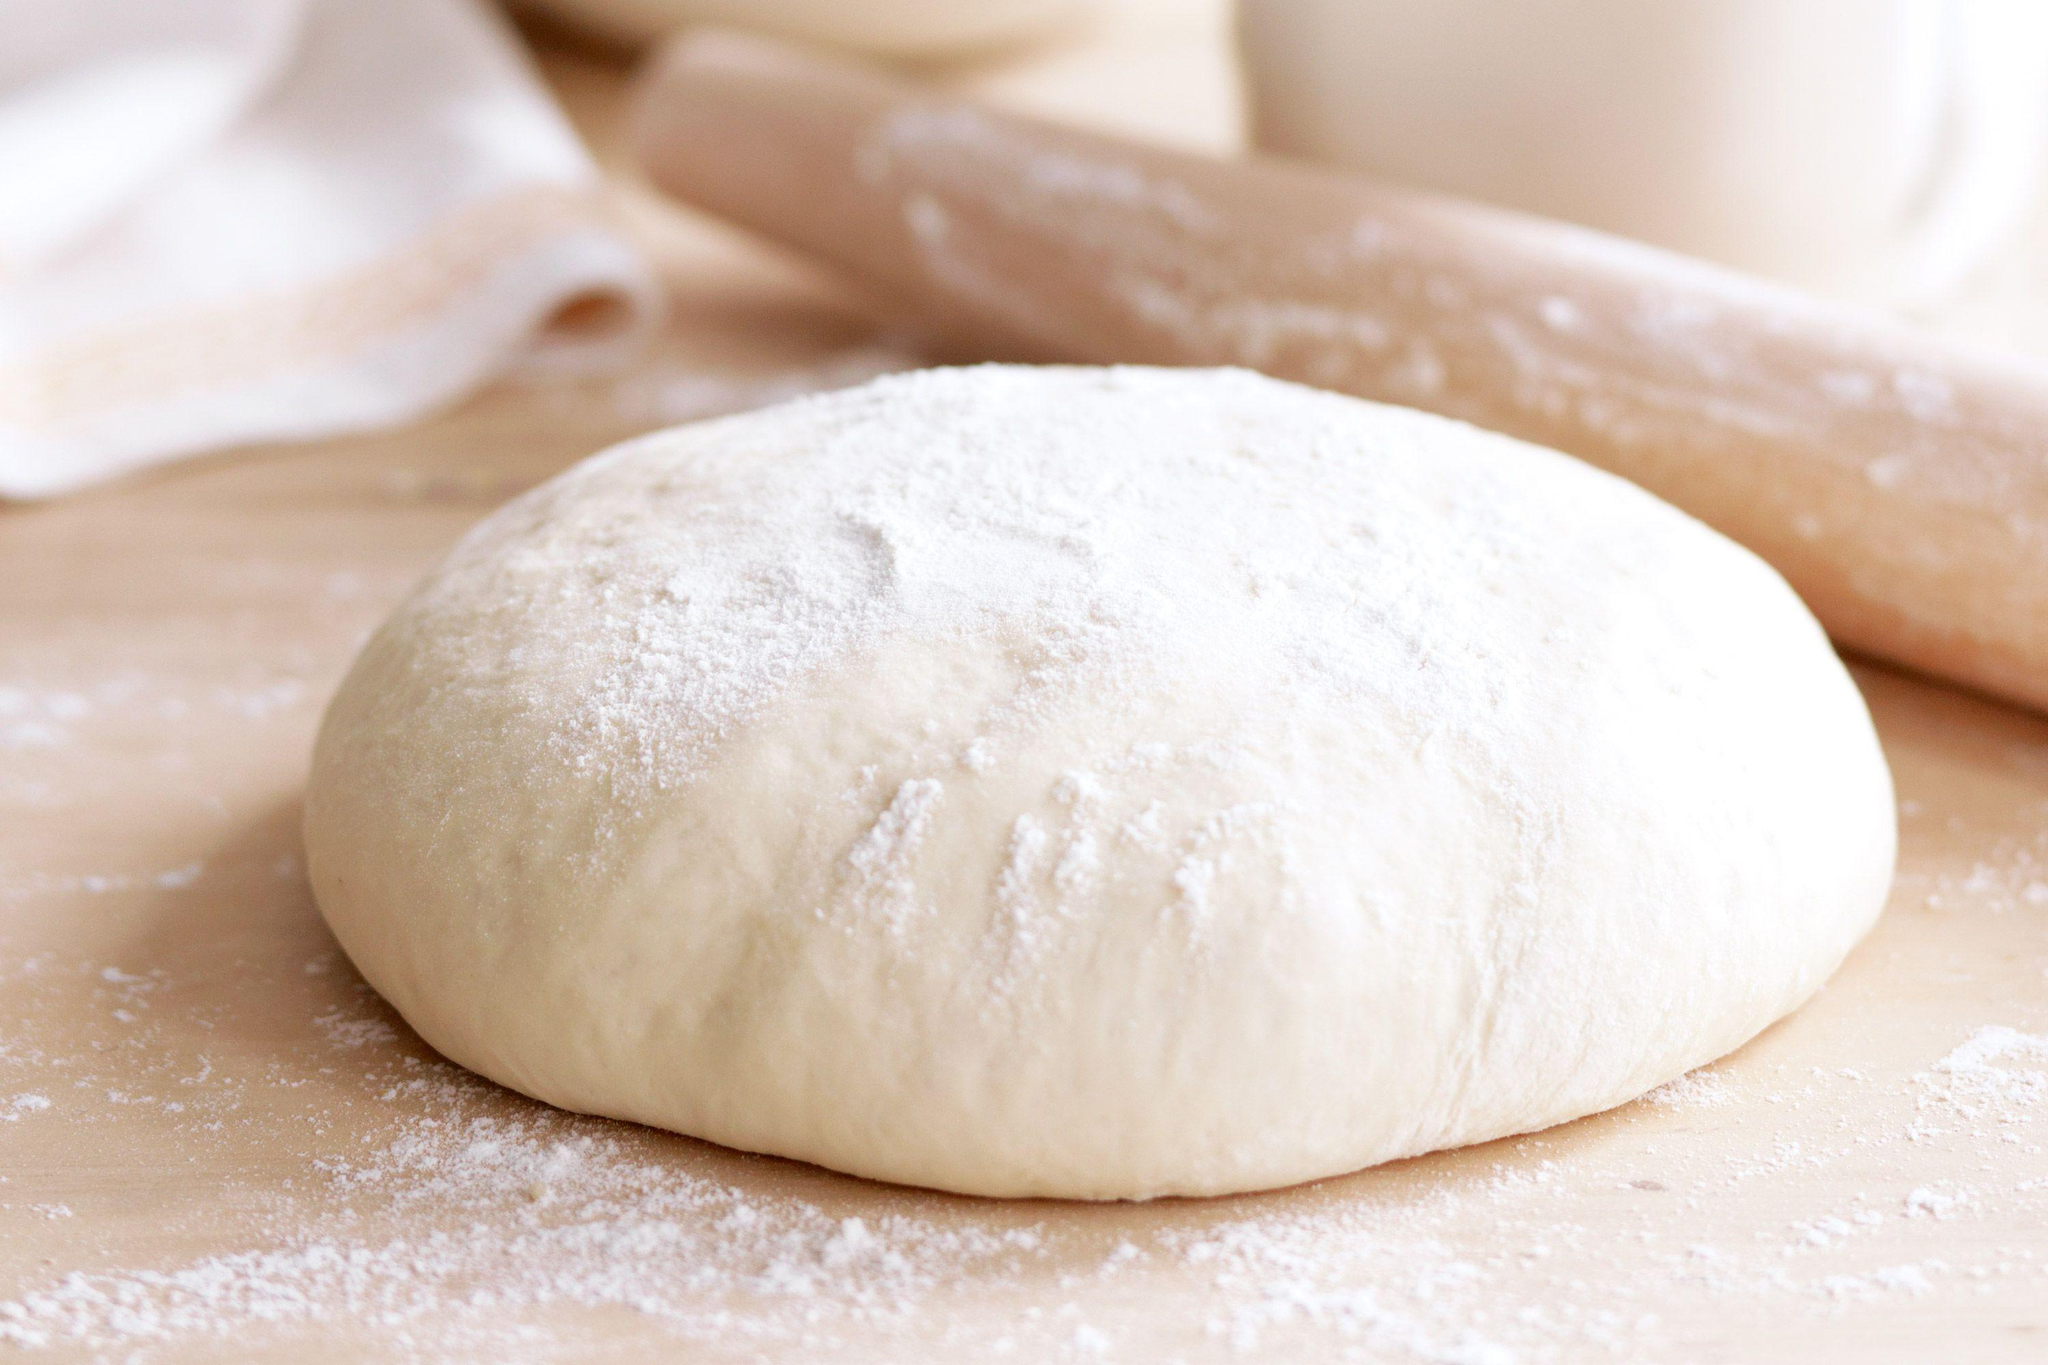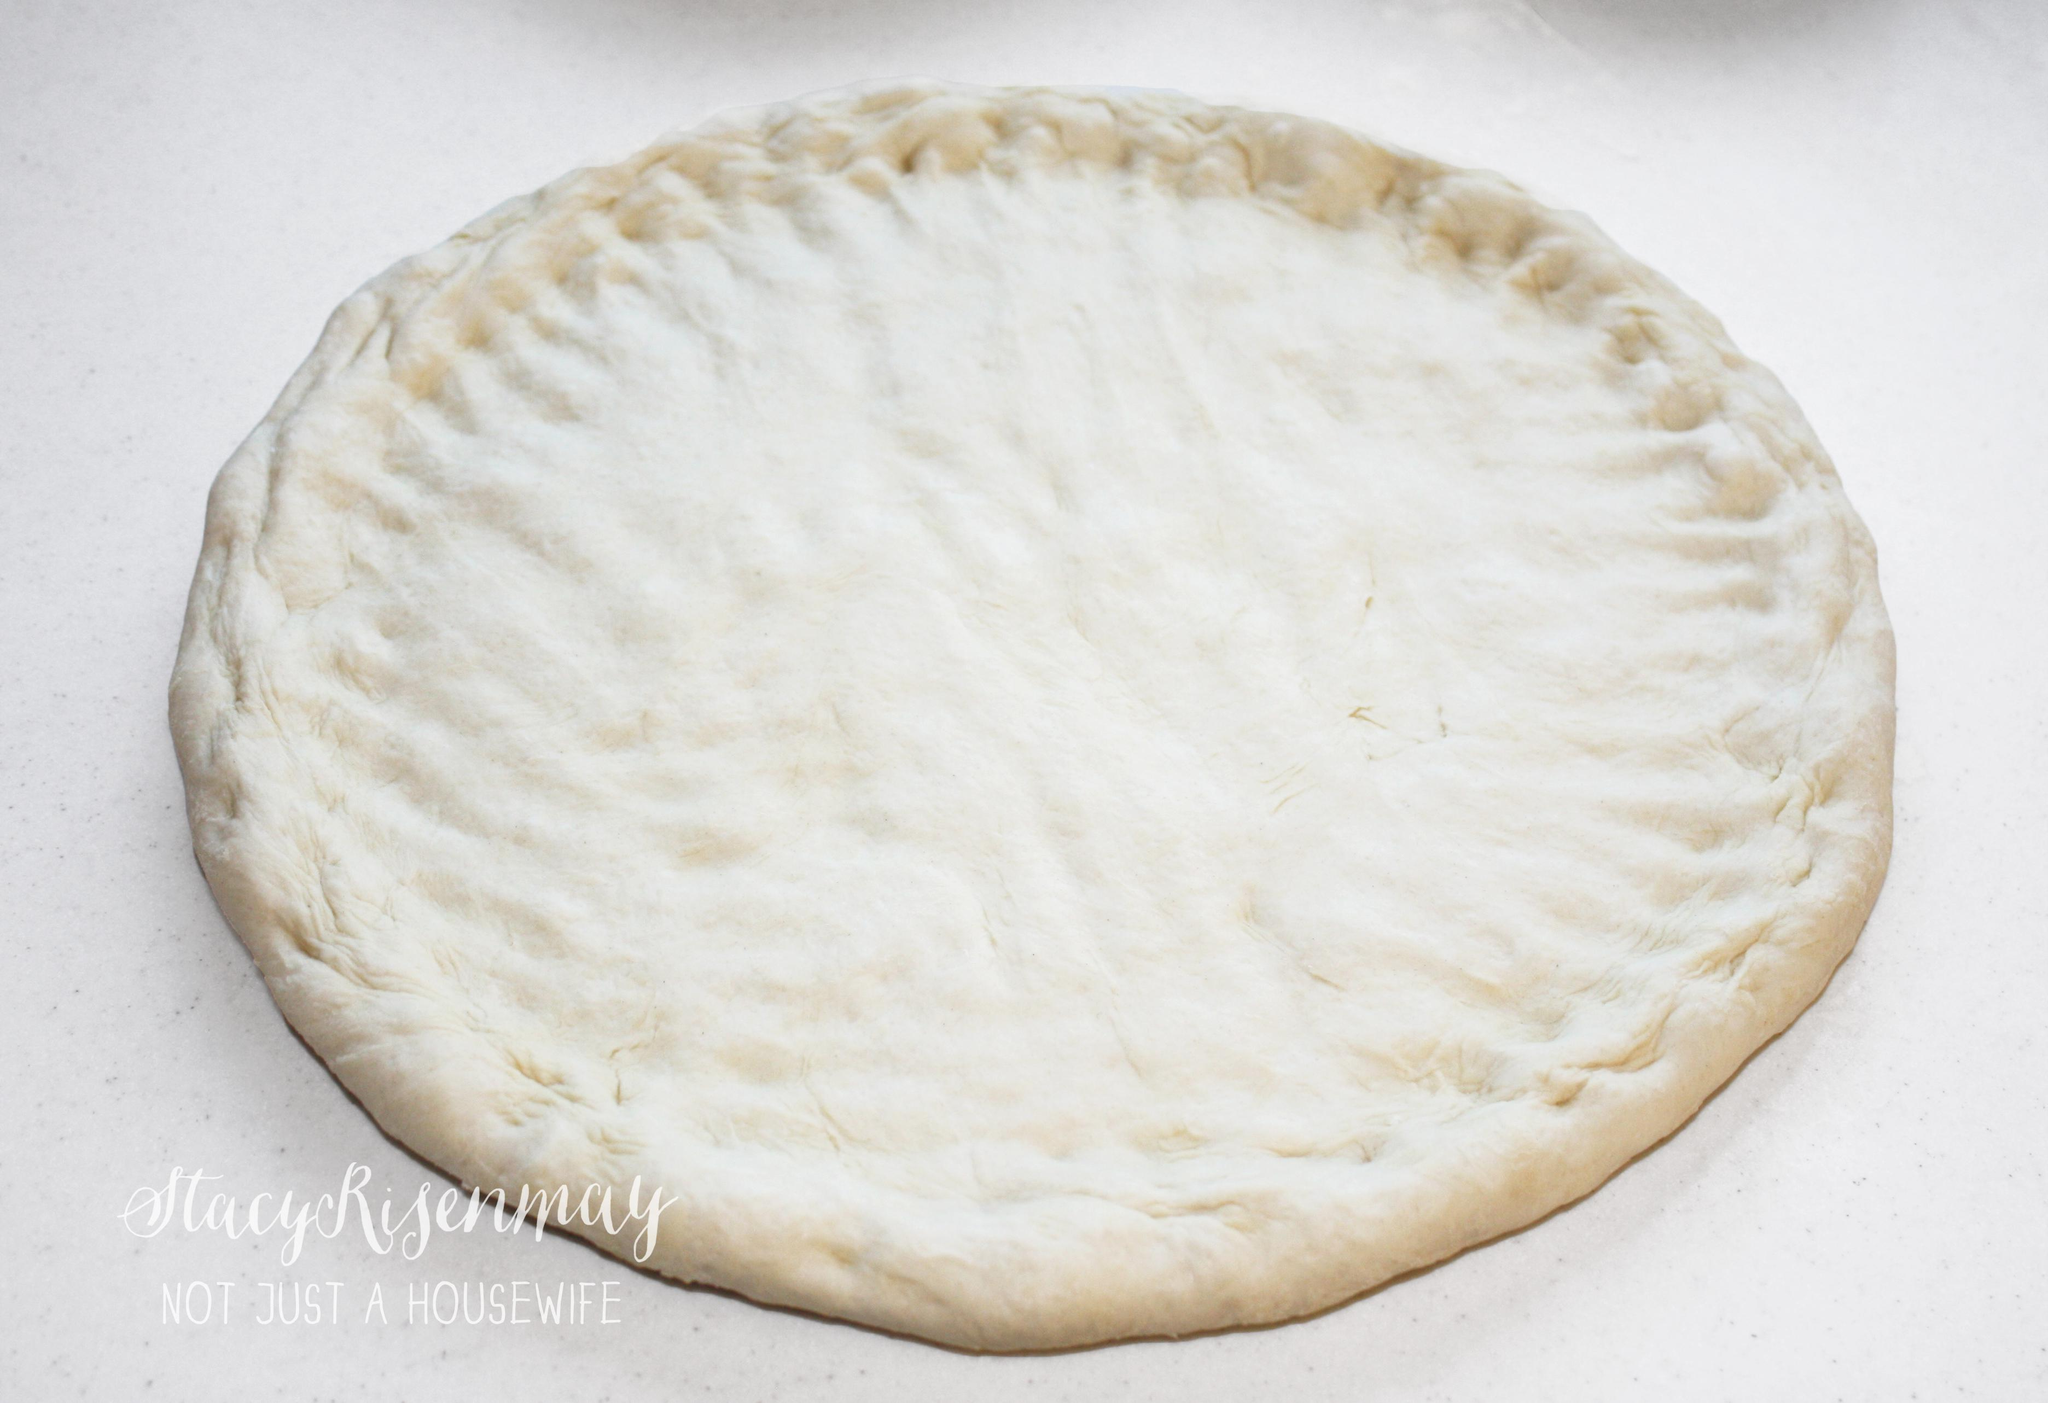The first image is the image on the left, the second image is the image on the right. Assess this claim about the two images: "In one image a ball of dough is resting on a flour-dusted surface, while a second image shows dough flattened into a round disk.". Correct or not? Answer yes or no. Yes. The first image is the image on the left, the second image is the image on the right. Examine the images to the left and right. Is the description "The dough has been flattened into a pizza crust shape in only one of the images." accurate? Answer yes or no. Yes. 